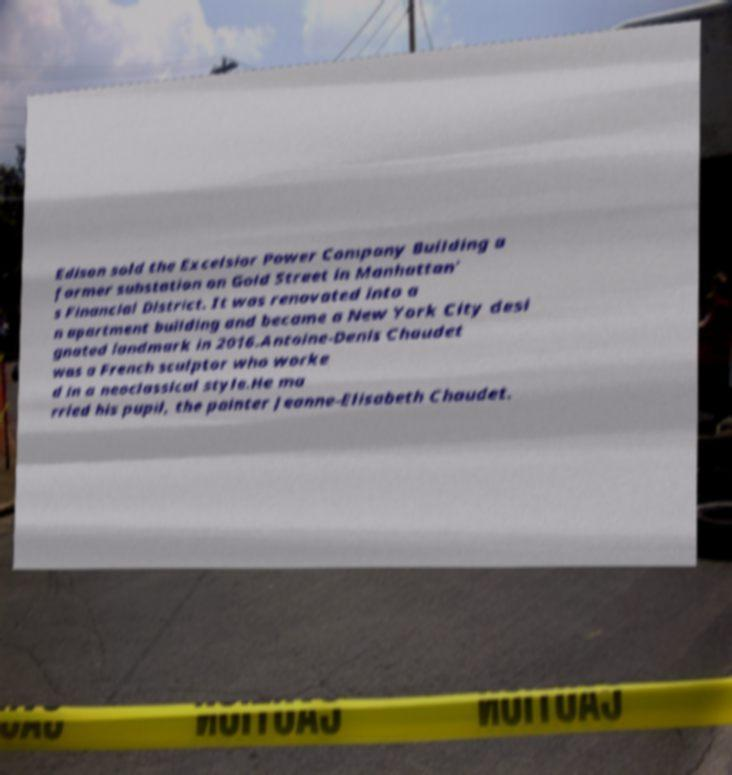What messages or text are displayed in this image? I need them in a readable, typed format. Edison sold the Excelsior Power Company Building a former substation on Gold Street in Manhattan' s Financial District. It was renovated into a n apartment building and became a New York City desi gnated landmark in 2016.Antoine-Denis Chaudet was a French sculptor who worke d in a neoclassical style.He ma rried his pupil, the painter Jeanne-Elisabeth Chaudet. 